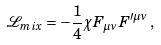<formula> <loc_0><loc_0><loc_500><loc_500>\mathcal { L } _ { m i x } = - \frac { 1 } { 4 } \chi F _ { \mu \nu } F ^ { \prime \mu \nu } \, ,</formula> 